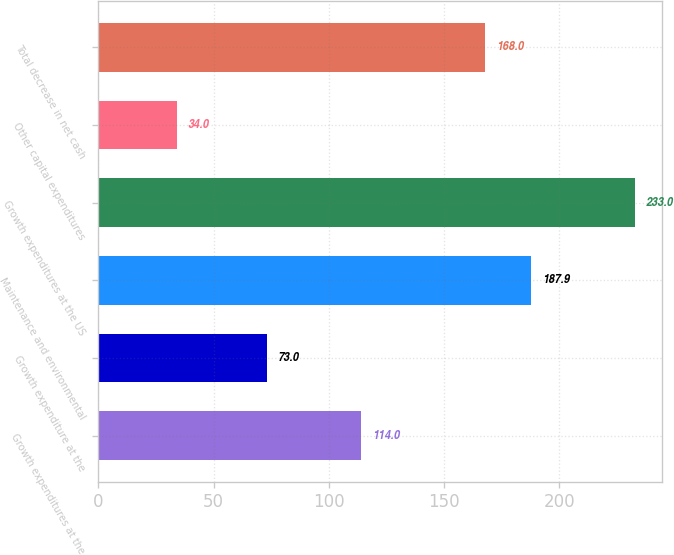Convert chart. <chart><loc_0><loc_0><loc_500><loc_500><bar_chart><fcel>Growth expenditures at the<fcel>Growth expenditure at the<fcel>Maintenance and environmental<fcel>Growth expenditures at the US<fcel>Other capital expenditures<fcel>Total decrease in net cash<nl><fcel>114<fcel>73<fcel>187.9<fcel>233<fcel>34<fcel>168<nl></chart> 